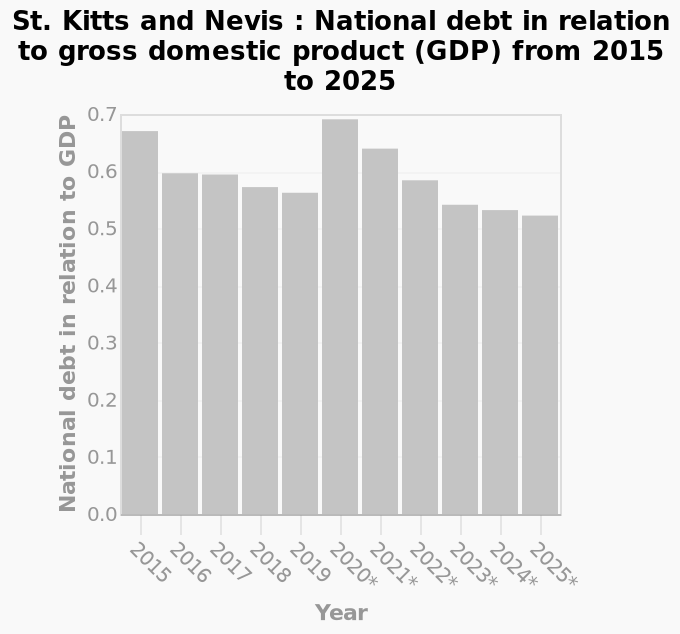<image>
Did the national debt increase or decrease in 2020? The national debt increased in 2020. How did the national debt trend from 2020 to 2025?  The national debt retained its downward trend from 2020-2025. Was there any change in the national debt trend between 2015 and 2019?  Yes, the national debt was on a downward trend between 2015 and 2019. 